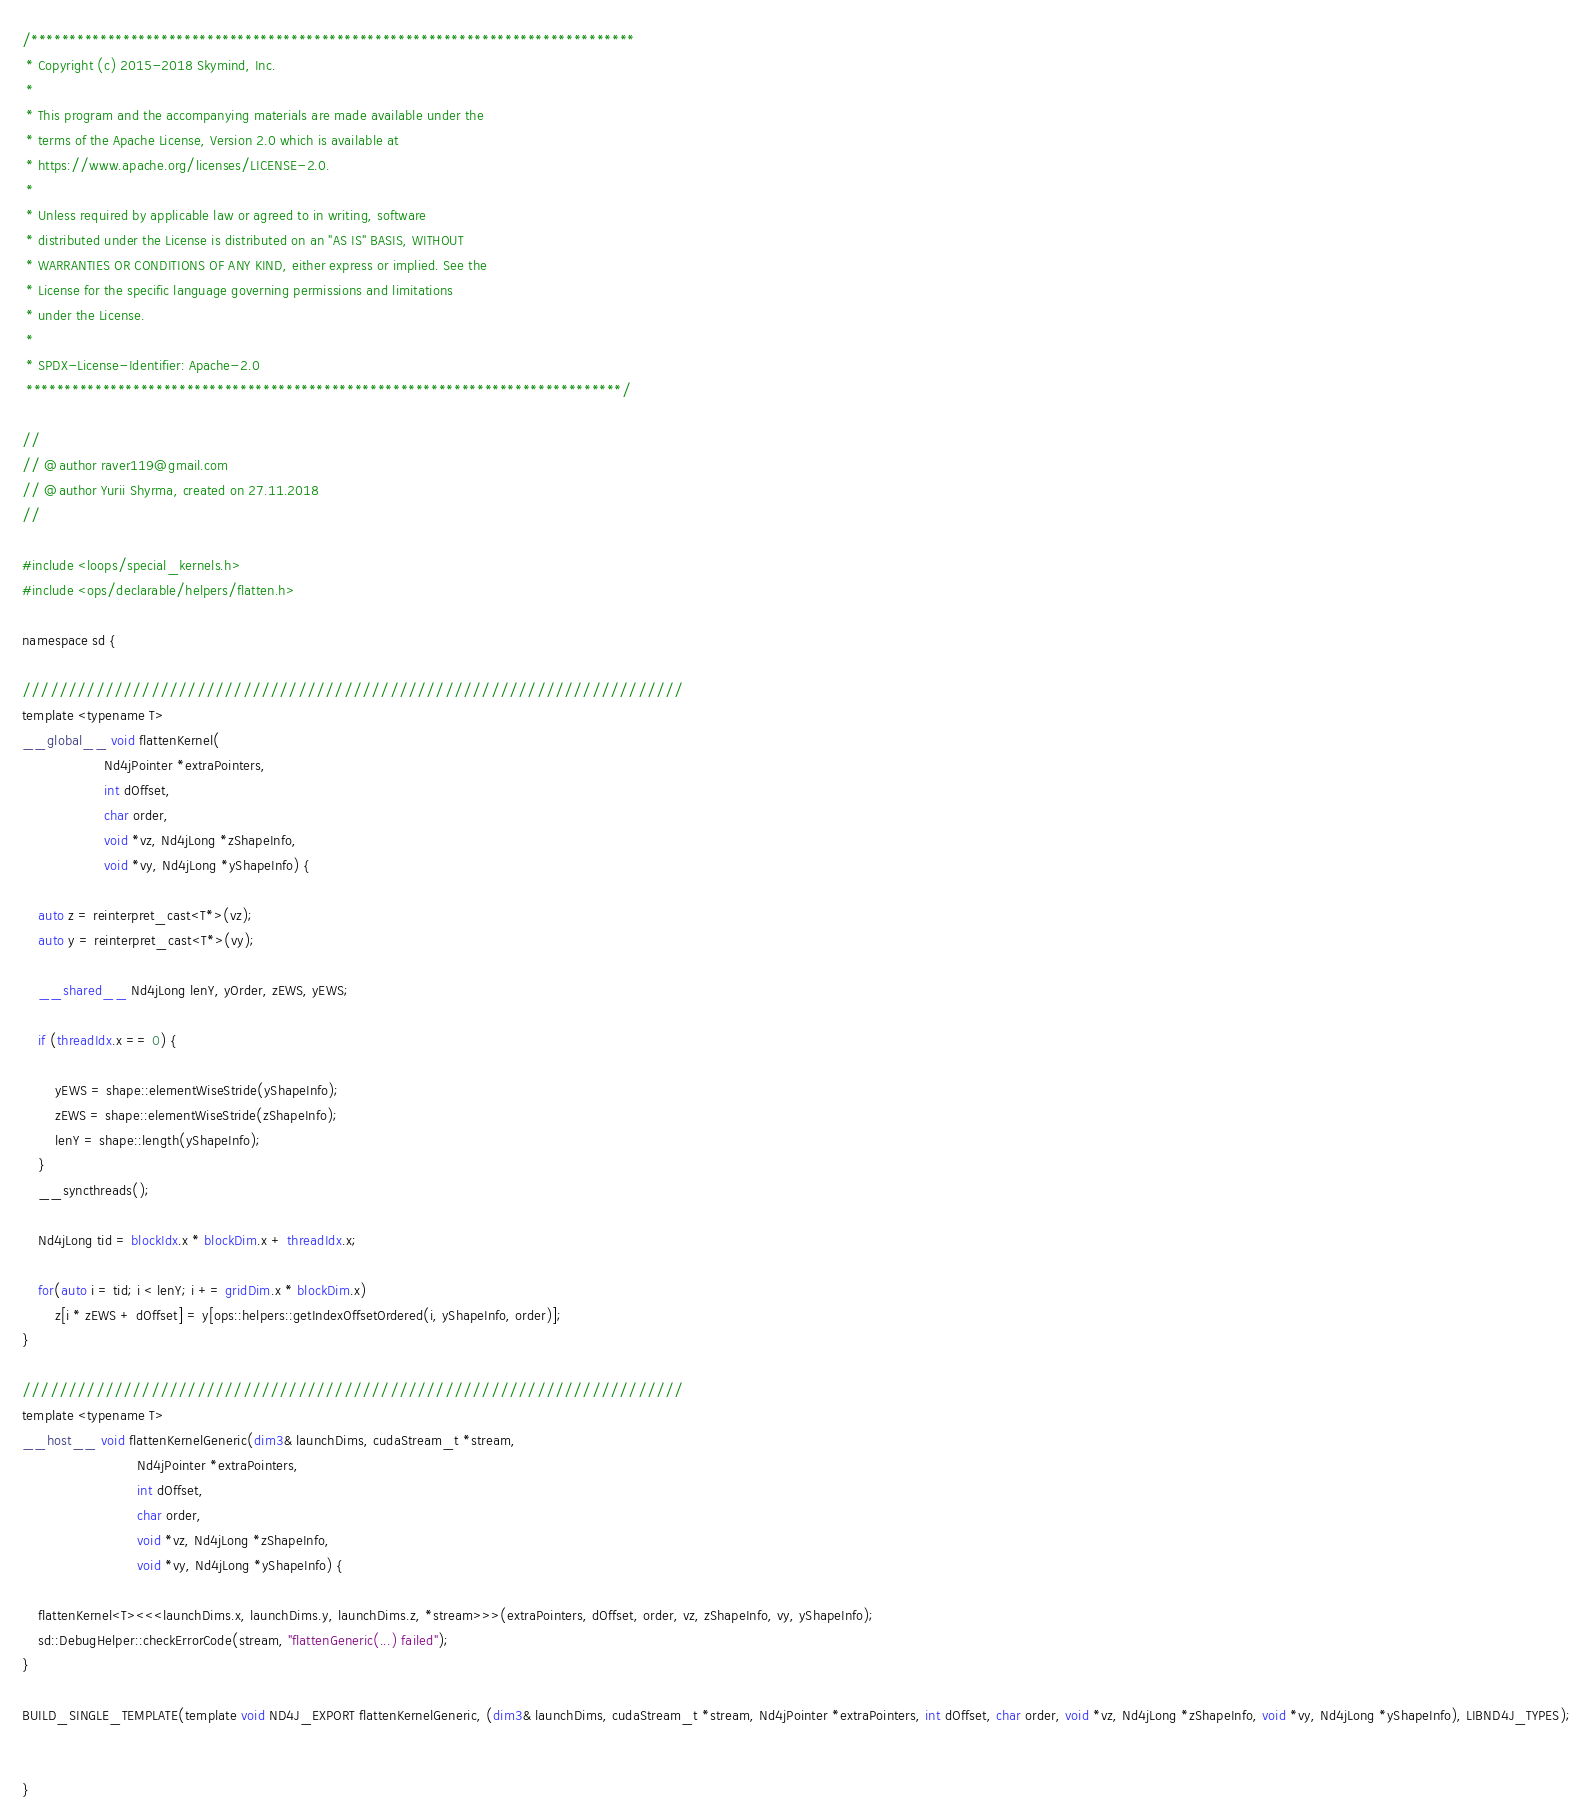Convert code to text. <code><loc_0><loc_0><loc_500><loc_500><_Cuda_>/*******************************************************************************
 * Copyright (c) 2015-2018 Skymind, Inc.
 *
 * This program and the accompanying materials are made available under the
 * terms of the Apache License, Version 2.0 which is available at
 * https://www.apache.org/licenses/LICENSE-2.0.
 *
 * Unless required by applicable law or agreed to in writing, software
 * distributed under the License is distributed on an "AS IS" BASIS, WITHOUT
 * WARRANTIES OR CONDITIONS OF ANY KIND, either express or implied. See the
 * License for the specific language governing permissions and limitations
 * under the License.
 *
 * SPDX-License-Identifier: Apache-2.0
 ******************************************************************************/

//
// @author raver119@gmail.com
// @author Yurii Shyrma, created on 27.11.2018
//

#include <loops/special_kernels.h>
#include <ops/declarable/helpers/flatten.h>

namespace sd {

////////////////////////////////////////////////////////////////////////
template <typename T>
__global__ void flattenKernel(
                    Nd4jPointer *extraPointers,
                    int dOffset,
                    char order,
                    void *vz, Nd4jLong *zShapeInfo,
                    void *vy, Nd4jLong *yShapeInfo) {

    auto z = reinterpret_cast<T*>(vz);
    auto y = reinterpret_cast<T*>(vy);

    __shared__ Nd4jLong lenY, yOrder, zEWS, yEWS;

    if (threadIdx.x == 0) {

        yEWS = shape::elementWiseStride(yShapeInfo);
        zEWS = shape::elementWiseStride(zShapeInfo);
        lenY = shape::length(yShapeInfo);
    }
    __syncthreads();

    Nd4jLong tid = blockIdx.x * blockDim.x + threadIdx.x;

    for(auto i = tid; i < lenY; i += gridDim.x * blockDim.x)
        z[i * zEWS + dOffset] = y[ops::helpers::getIndexOffsetOrdered(i, yShapeInfo, order)];
}

////////////////////////////////////////////////////////////////////////
template <typename T>
__host__ void flattenKernelGeneric(dim3& launchDims, cudaStream_t *stream,
                            Nd4jPointer *extraPointers,
                            int dOffset,
                            char order,
                            void *vz, Nd4jLong *zShapeInfo,
                            void *vy, Nd4jLong *yShapeInfo) {

    flattenKernel<T><<<launchDims.x, launchDims.y, launchDims.z, *stream>>>(extraPointers, dOffset, order, vz, zShapeInfo, vy, yShapeInfo);
    sd::DebugHelper::checkErrorCode(stream, "flattenGeneric(...) failed");
}

BUILD_SINGLE_TEMPLATE(template void ND4J_EXPORT flattenKernelGeneric, (dim3& launchDims, cudaStream_t *stream, Nd4jPointer *extraPointers, int dOffset, char order, void *vz, Nd4jLong *zShapeInfo, void *vy, Nd4jLong *yShapeInfo), LIBND4J_TYPES);


}</code> 